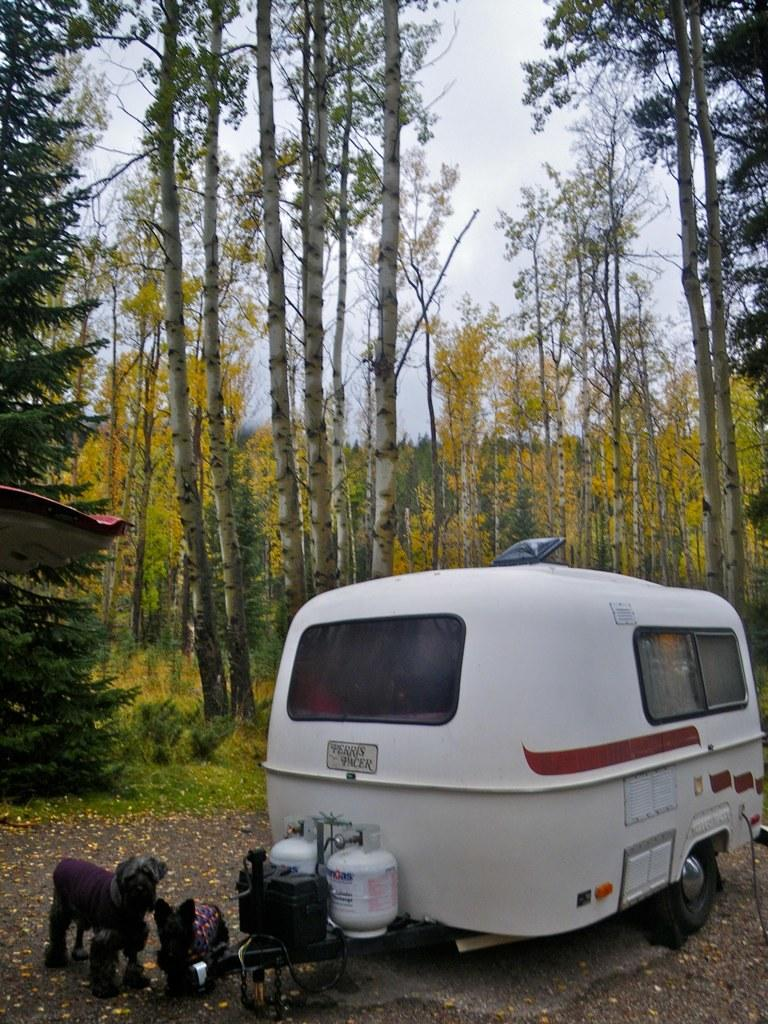What is the main subject in the center of the image? There is a vehicle in the center of the image. Are there any animals visible in the image? Yes, there are two dogs in the image. What can be seen in the background of the image? There are trees, plants, and the sky visible in the background of the image. What type of iron is being used by the dogs in the image? There is no iron present in the image, and the dogs are not using any tools or equipment. 